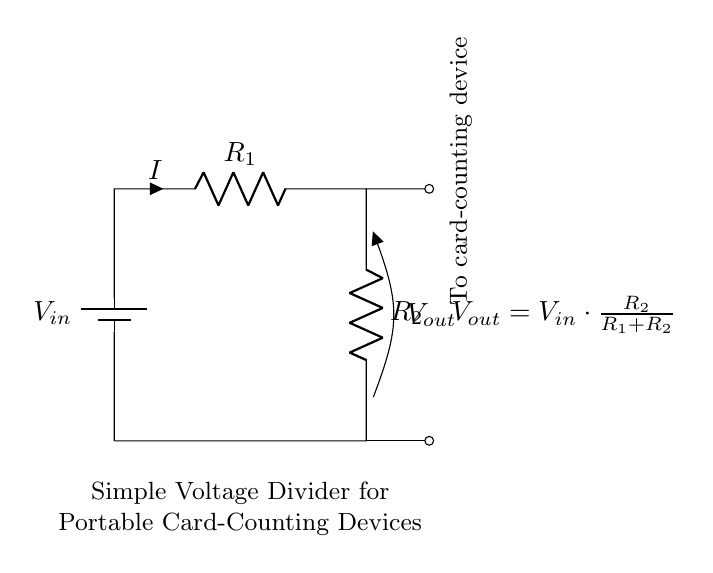What is the input voltage of the circuit? The input voltage is denoted as V in the circuit diagram, which is represented by the battery symbol at the left side.
Answer: V in What is the output voltage formula? The output voltage is given by the formula shown in the diagram, which is V out equals V in multiplied by the fraction of R2 over the sum of R1 and R2. This indicates the relationship between the input and the output based on the resistors.
Answer: V out = V in * (R2 / (R1 + R2)) What do the resistors R1 and R2 do in the circuit? R1 and R2 are components that create a voltage divider effect, determining how the input voltage is divided to produce a lower output voltage for the card-counting device. R1 is the resistor in series and R2 is the resistor in parallel.
Answer: Reduce voltage What is the direction of current in the diagram? The direction of current is shown by the arrow labeled I, flowing through R1 first and then through R2, indicating the path of current flow in the voltage divider circuit.
Answer: Downwards What is the function of V out in this circuit? V out, shown at the bottom of R2, represents the voltage that is supplied to the card-counting device, ensuring it operates correctly with a lowered voltage from the input.
Answer: Power card-counting device How can you calculate the total resistance in this voltage divider? The total resistance in this voltage divider can be found by adding the resistances of R1 and R2 together since they are in series for the purpose of calculating the output voltage.
Answer: R1 + R2 